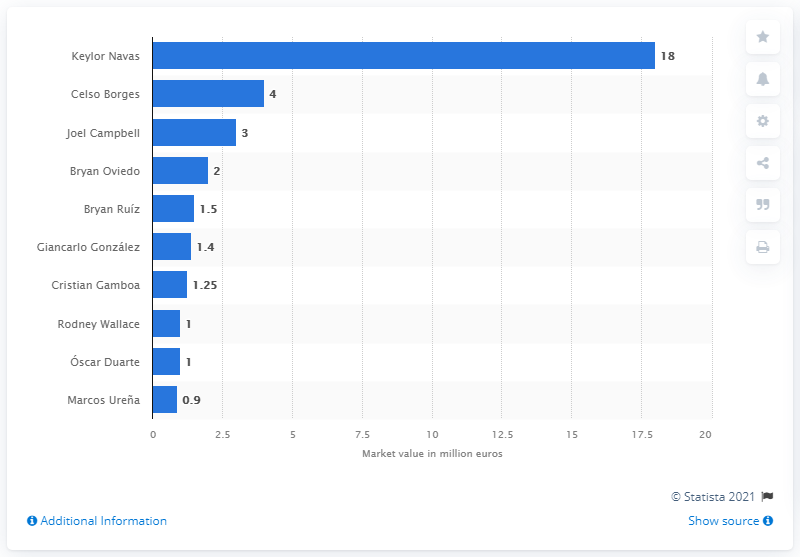Give some essential details in this illustration. Keylor Navas' market value was 18 million dollars. As of June 2018, the most valuable Costa Rican soccer player was Keylor Navas. Celso Borges was the second most valuable Costa Rican soccer player. 